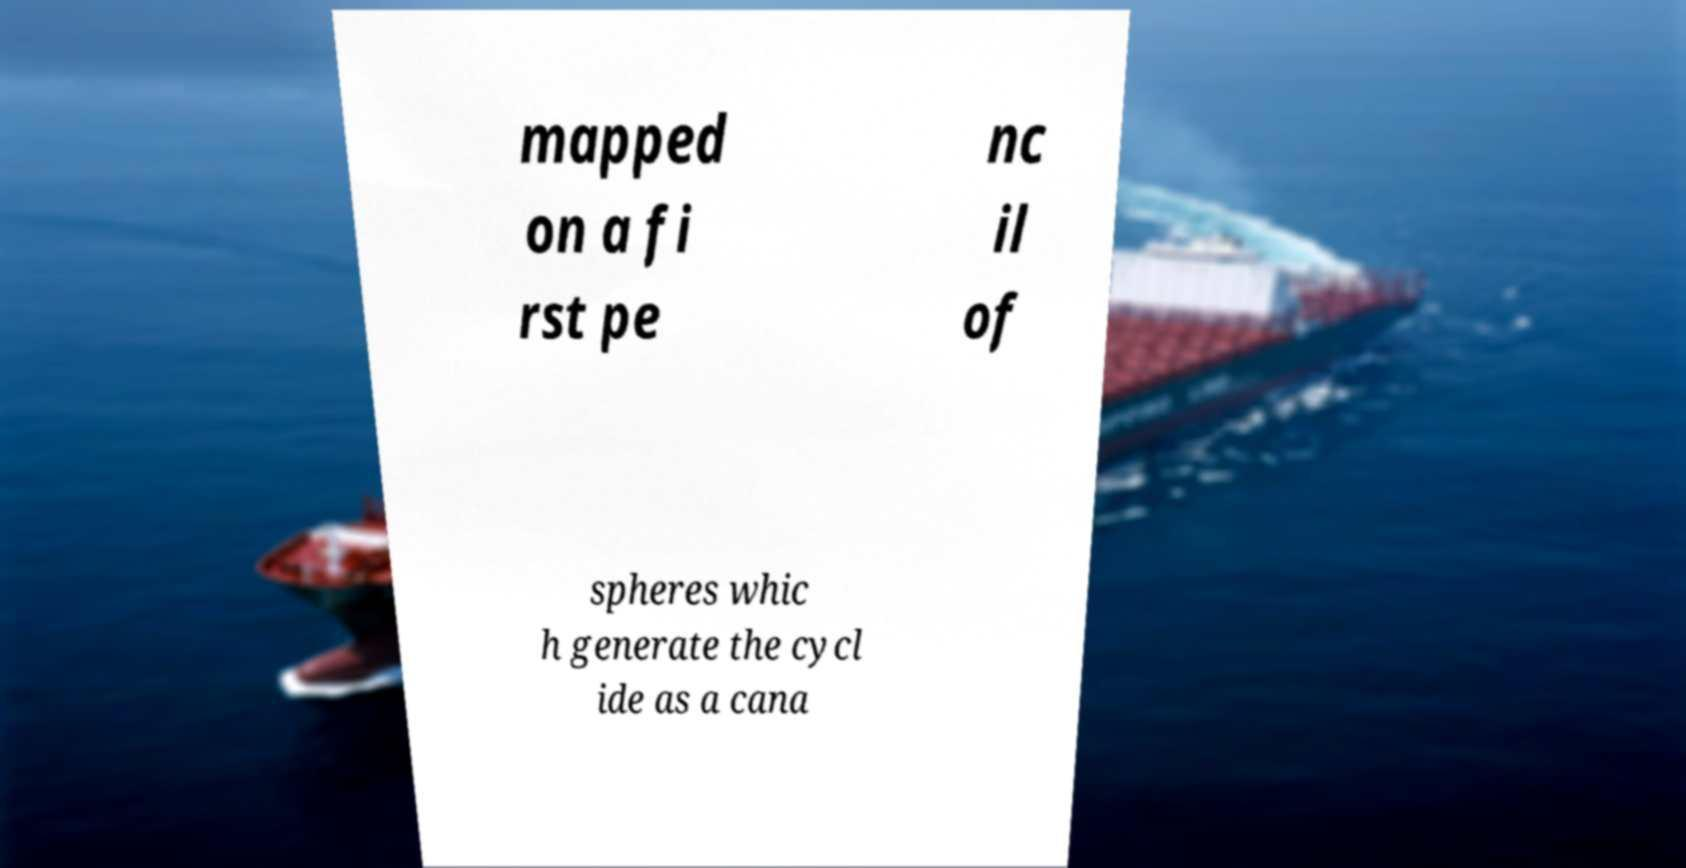Can you read and provide the text displayed in the image?This photo seems to have some interesting text. Can you extract and type it out for me? mapped on a fi rst pe nc il of spheres whic h generate the cycl ide as a cana 